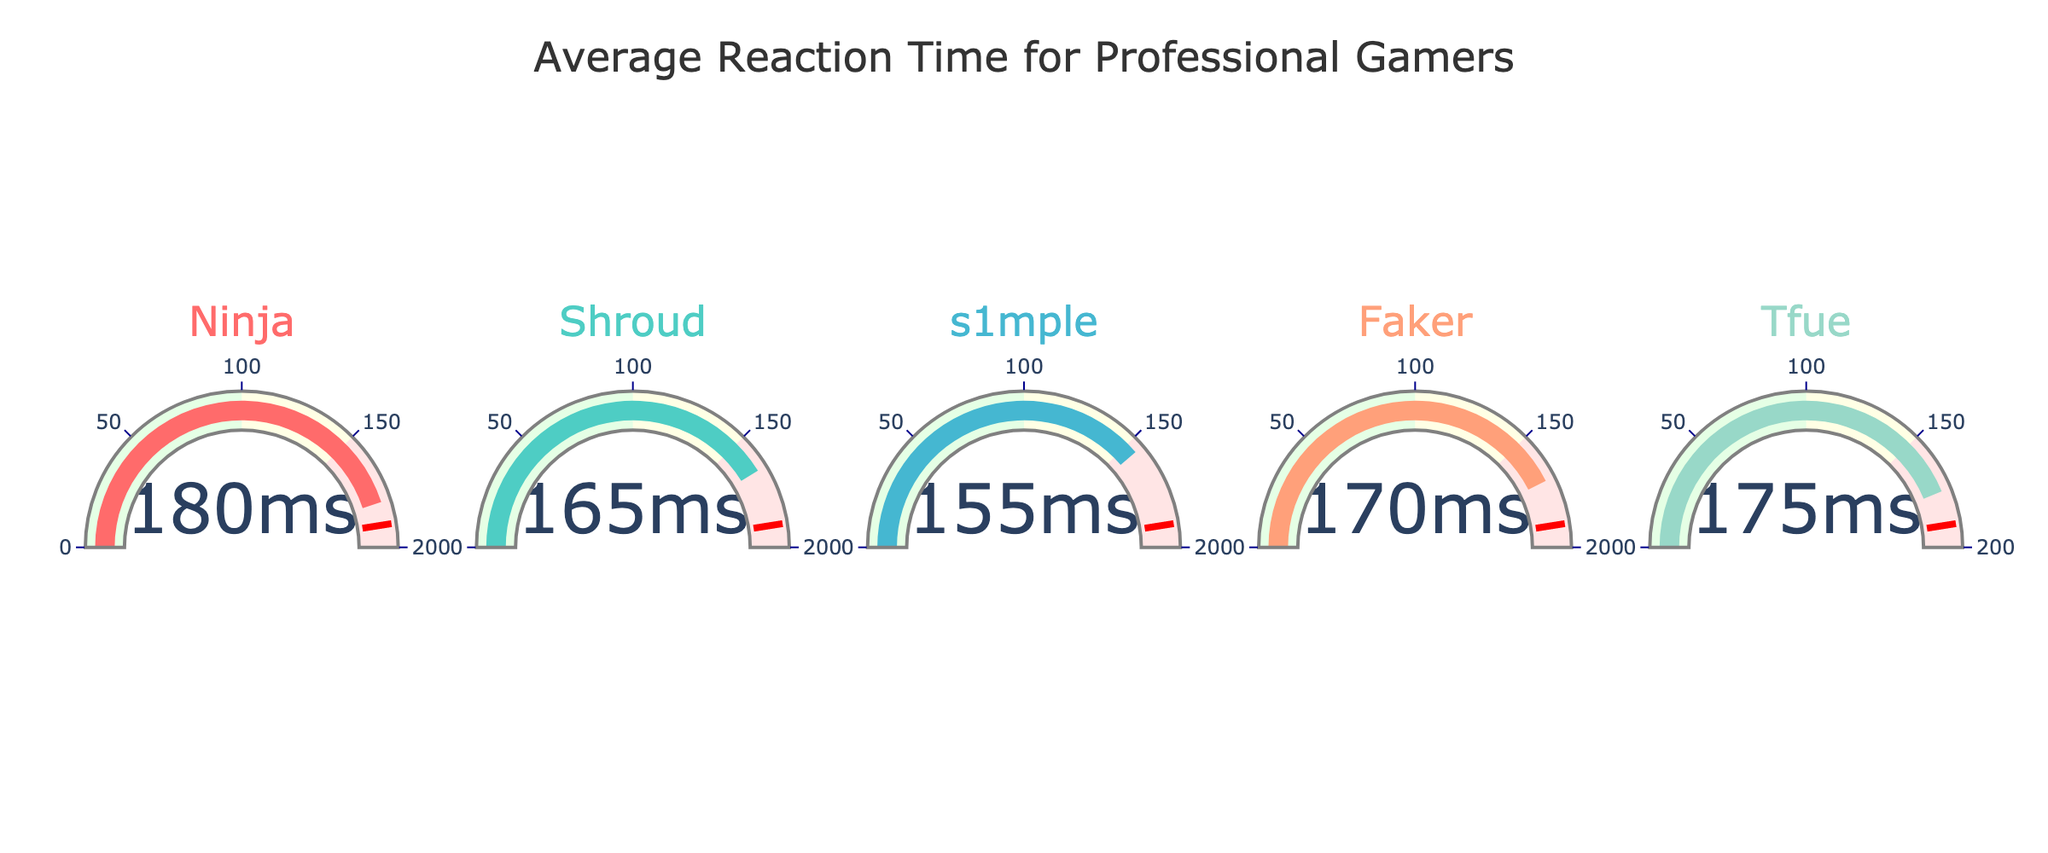How many players are represented in the gauge chart? The gauge chart shows one gauge for each player. By counting the individual gauges, we can see that there are 5 players represented.
Answer: 5 Which player has the fastest average reaction time? By comparing the values shown on each gauge, we see that the player with the lowest number has the fastest reaction time. s1mple has the fastest reaction time at 155 ms.
Answer: s1mple What is the range of reaction times displayed in the chart? To find the range, we need the highest and lowest values. The highest reaction time is Ninja with 180 ms, and the lowest is s1mple with 155 ms. The range is 180 - 155 = 25 ms.
Answer: 25 ms Who has a slower reaction time, Faker or Tfue? By comparing the reaction times on the gauges, Faker has a reaction time of 170 ms while Tfue has a reaction time of 175 ms. Therefore, Tfue has a slower reaction time.
Answer: Tfue What is the combined average reaction time of Ninja and Shroud? The reaction times are 180 ms for Ninja and 165 ms for Shroud. The combined average is calculated by adding these two and dividing by 2. (180 + 165) / 2 = 172.5 ms.
Answer: 172.5 ms Is Shroud's reaction time faster than Faker's? Comparing the values, Shroud has a reaction time of 165 ms, and Faker has a reaction time of 170 ms. Since 165 ms is less than 170 ms, Shroud's reaction time is faster.
Answer: Yes Which player has a reaction time closest to 175 ms? By reviewing the reaction times displayed, Tfue has a reaction time that is exactly 175 ms, which is closest to the queried value.
Answer: Tfue Between Ninja and s1mple, who has a better (faster) reaction time, and by how much? s1mple has a reaction time of 155 ms, and Ninja has 180 ms. The difference is 180 - 155 = 25 ms. Therefore, s1mple is 25 ms faster than Ninja.
Answer: s1mple by 25 ms Arrange the players in descending order of their reaction times. By reviewing the reaction times: 1) Ninja - 180 ms, 2) Tfue - 175 ms, 3) Faker - 170 ms, 4) Shroud - 165 ms, 5) s1mple - 155 ms. So, the order is Ninja > Tfue > Faker > Shroud > s1mple.
Answer: Ninja, Tfue, Faker, Shroud, s1mple 